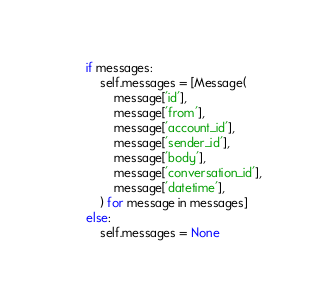<code> <loc_0><loc_0><loc_500><loc_500><_Python_>        if messages:
            self.messages = [Message(
                message['id'],
                message['from'],
                message['account_id'],
                message['sender_id'],
                message['body'],
                message['conversation_id'],
                message['datetime'],
            ) for message in messages]
        else:
            self.messages = None
</code> 